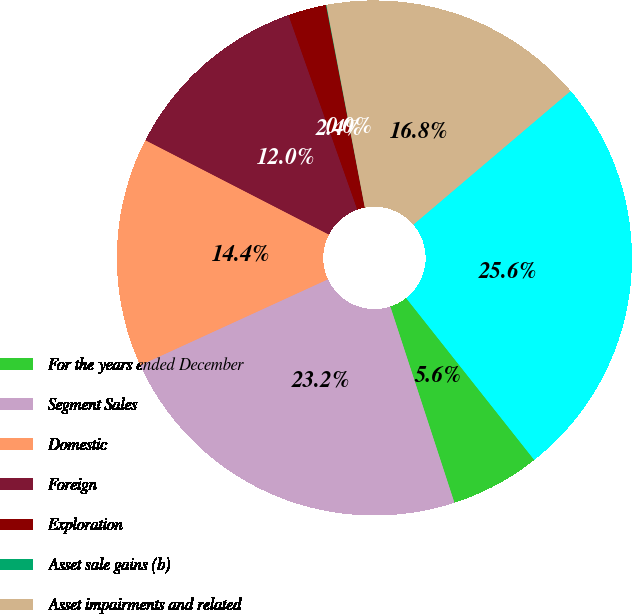Convert chart to OTSL. <chart><loc_0><loc_0><loc_500><loc_500><pie_chart><fcel>For the years ended December<fcel>Segment Sales<fcel>Domestic<fcel>Foreign<fcel>Exploration<fcel>Asset sale gains (b)<fcel>Asset impairments and related<fcel>Total Oil and Gas<nl><fcel>5.63%<fcel>23.19%<fcel>14.4%<fcel>12.03%<fcel>2.4%<fcel>0.03%<fcel>16.77%<fcel>25.56%<nl></chart> 